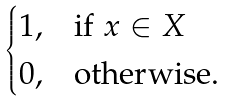<formula> <loc_0><loc_0><loc_500><loc_500>\begin{cases} 1 , & \text {if $x\in X$} \\ 0 , & \text {otherwise.} \end{cases}</formula> 